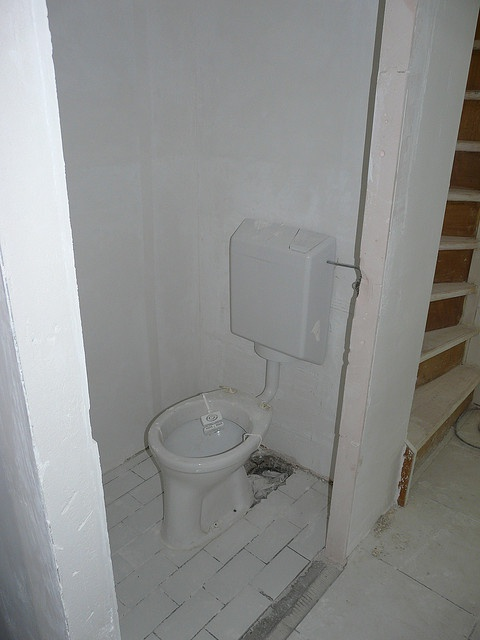Describe the objects in this image and their specific colors. I can see a toilet in lightgray and gray tones in this image. 